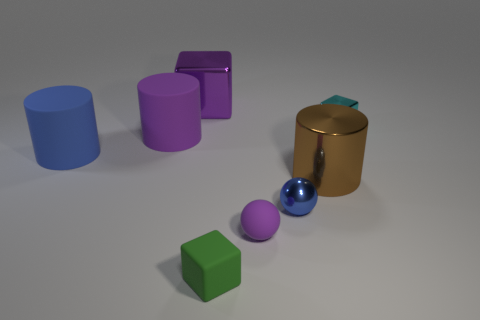Are there more purple shiny cubes that are in front of the green thing than big blue cylinders on the right side of the big brown metal cylinder?
Your answer should be very brief. No. Is there a big blue metallic object that has the same shape as the small purple object?
Give a very brief answer. No. There is a metal object to the left of the tiny matte object that is behind the matte cube; how big is it?
Provide a short and direct response. Large. What shape is the tiny thing that is right of the tiny metal thing that is in front of the small metal object that is behind the small blue object?
Provide a succinct answer. Cube. There is a cylinder that is made of the same material as the large blue object; what is its size?
Make the answer very short. Large. Are there more small green balls than cylinders?
Offer a very short reply. No. What material is the blue object that is the same size as the matte sphere?
Your answer should be compact. Metal. Does the cylinder on the right side of the rubber sphere have the same size as the tiny blue sphere?
Keep it short and to the point. No. How many spheres are blue metallic objects or cyan objects?
Your answer should be compact. 1. There is a large object that is right of the small green rubber cube; what is its material?
Provide a short and direct response. Metal. 